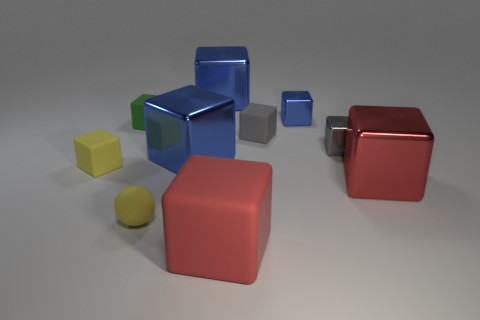Is there anything else that is the same shape as the tiny gray rubber thing?
Keep it short and to the point. Yes. What is the material of the block that is the same color as the small rubber ball?
Give a very brief answer. Rubber. Is the number of big red things to the right of the red rubber block the same as the number of green cubes?
Your response must be concise. Yes. There is a red matte thing; are there any yellow spheres behind it?
Provide a short and direct response. Yes. Is the shape of the tiny green matte object the same as the red thing in front of the red shiny object?
Provide a short and direct response. Yes. What color is the small cube that is made of the same material as the tiny blue thing?
Keep it short and to the point. Gray. The small matte ball is what color?
Your answer should be very brief. Yellow. Do the small green thing and the small block that is on the right side of the tiny blue metal block have the same material?
Offer a terse response. No. What number of metal objects are both to the right of the red rubber block and in front of the small green matte block?
Offer a terse response. 2. What is the shape of the blue thing that is the same size as the yellow sphere?
Offer a terse response. Cube. 